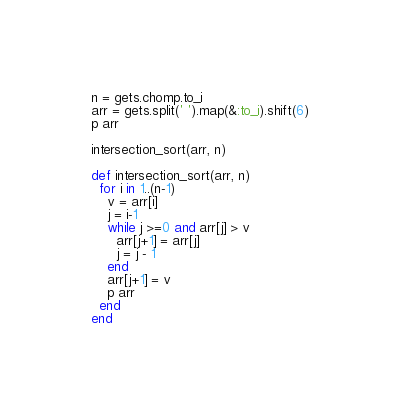Convert code to text. <code><loc_0><loc_0><loc_500><loc_500><_Ruby_>n = gets.chomp.to_i
arr = gets.split(' ').map(&:to_i).shift(6)
p arr

intersection_sort(arr, n)

def intersection_sort(arr, n)
  for i in 1..(n-1)
    v = arr[i]
    j = i-1
    while j >=0 and arr[j] > v
      arr[j+1] = arr[j]
      j = j - 1
    end
    arr[j+1] = v
    p arr
  end
end

</code> 